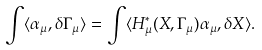<formula> <loc_0><loc_0><loc_500><loc_500>\int \langle \alpha _ { \mu } , \delta \Gamma _ { \mu } \rangle = \int \langle H _ { \mu } ^ { \ast } ( X , \Gamma _ { \mu } ) \alpha _ { \mu } , \delta X \rangle .</formula> 